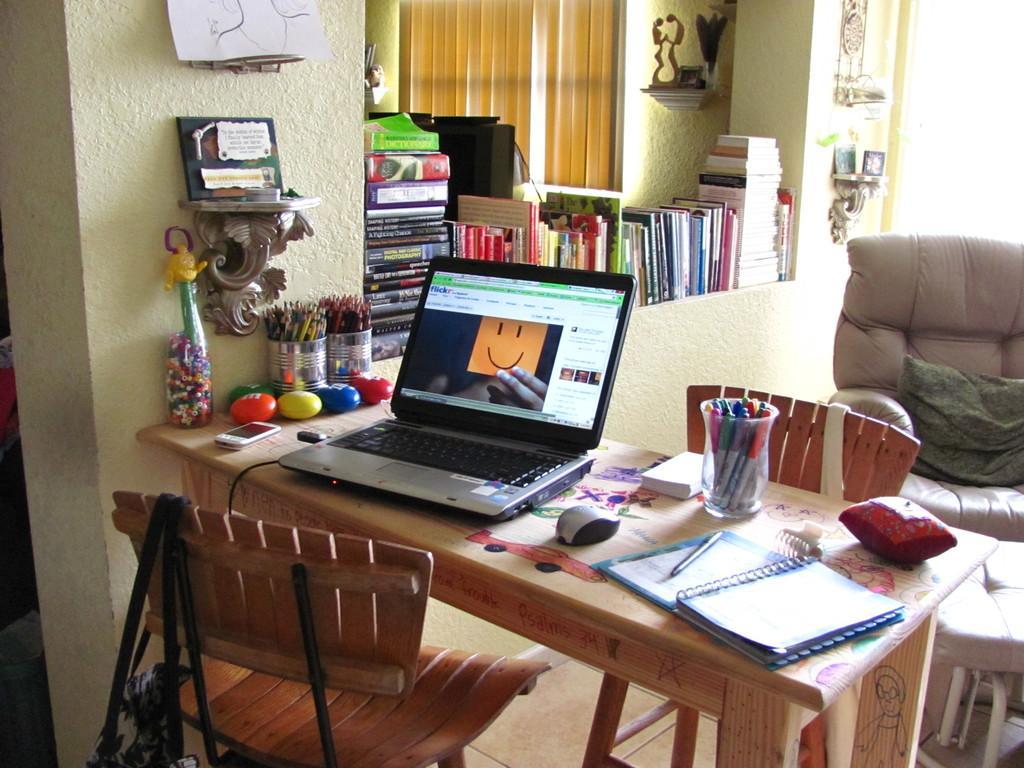Please provide a concise description of this image. Here is a table on which we can find laptop and mouse,book,pen,plucker,a small pillow and a glass filled with pens,mobile phone and also color pencils. Here are two chairs, one on opposite of each. A bag is hanged to this chair. Beside this table,we find wall which is light yellow in color. Beside this wall, we find many books or a bunch of books placed on wall. Next to it, we find a sofa chair and a pillow which is dark green in color. 